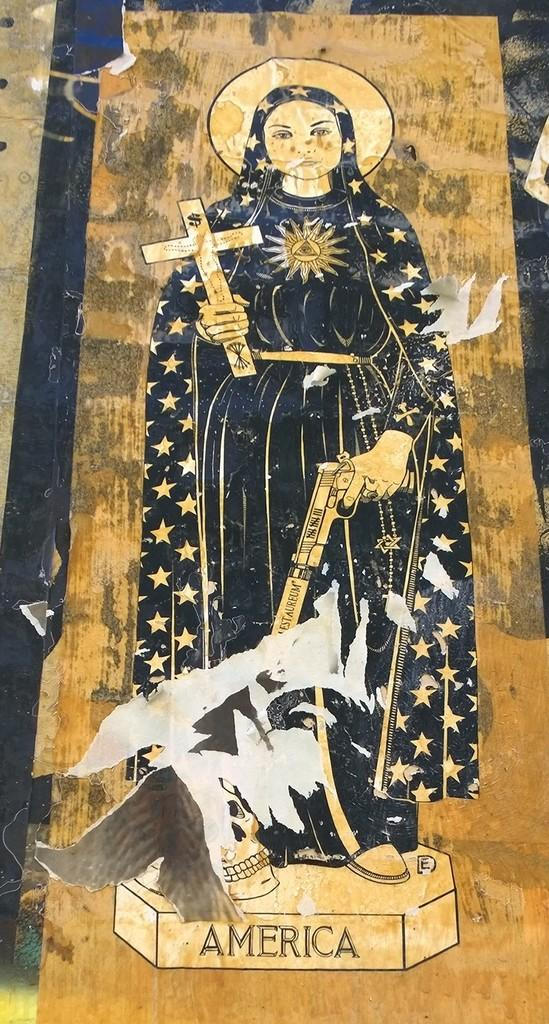What is the main subject in the foreground of the image? There is a painting in the foreground of the image. What is the painting mounted on? The painting is on a wooden plank. What type of hair can be seen in the painting? There is no hair visible in the painting, as the provided facts do not mention any human or animal figures with hair. 